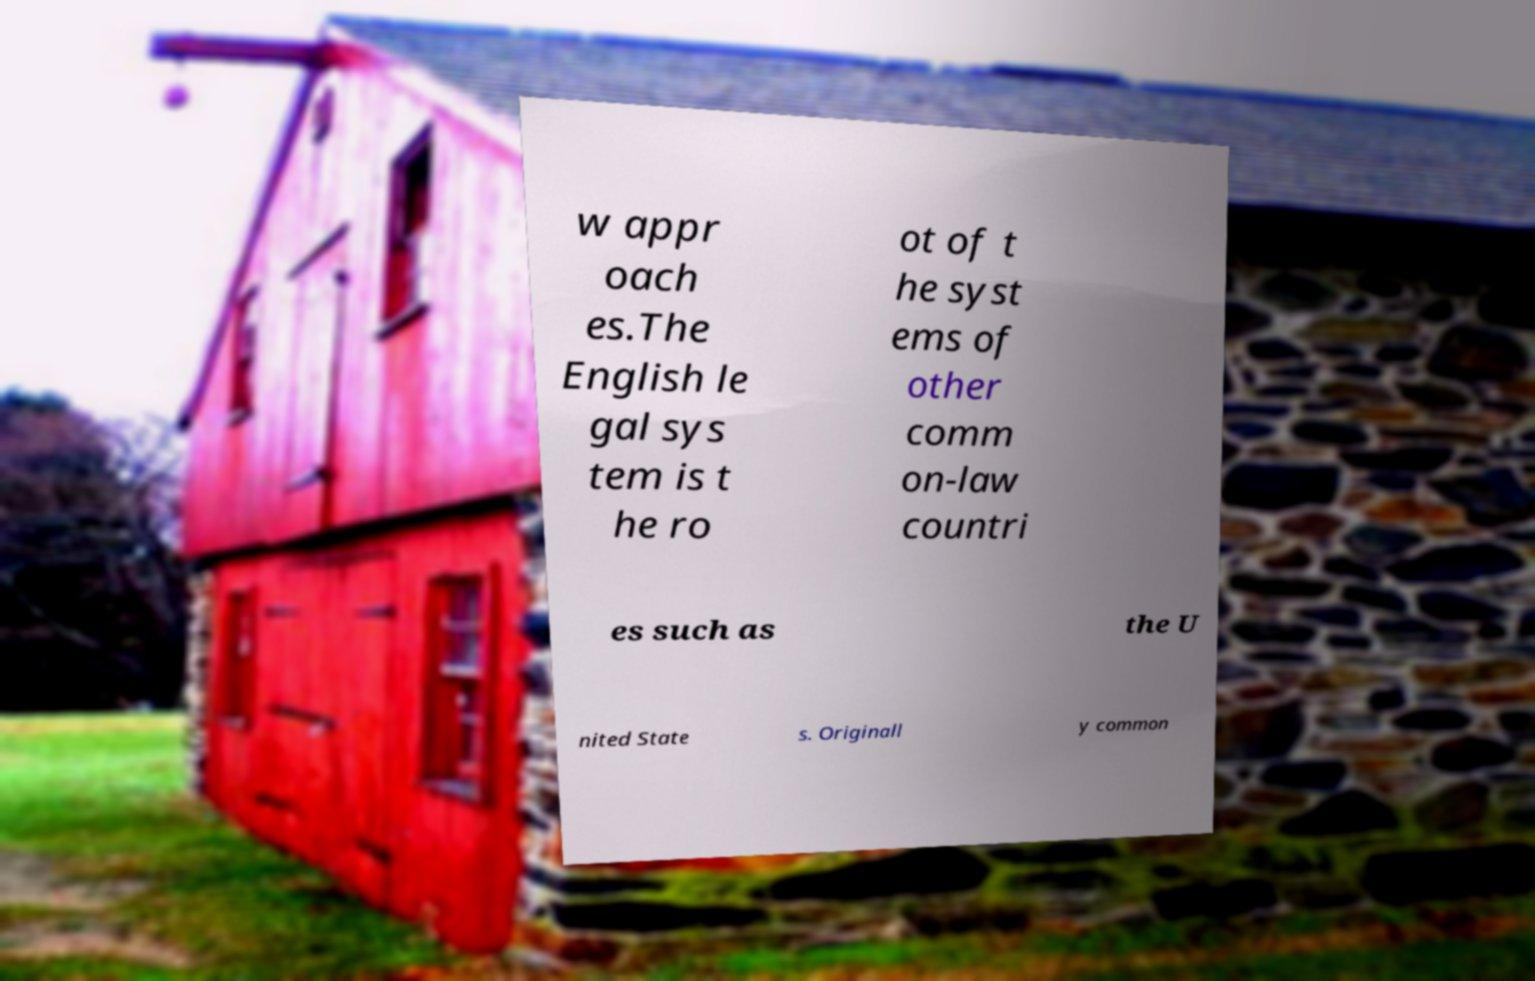What messages or text are displayed in this image? I need them in a readable, typed format. w appr oach es.The English le gal sys tem is t he ro ot of t he syst ems of other comm on-law countri es such as the U nited State s. Originall y common 